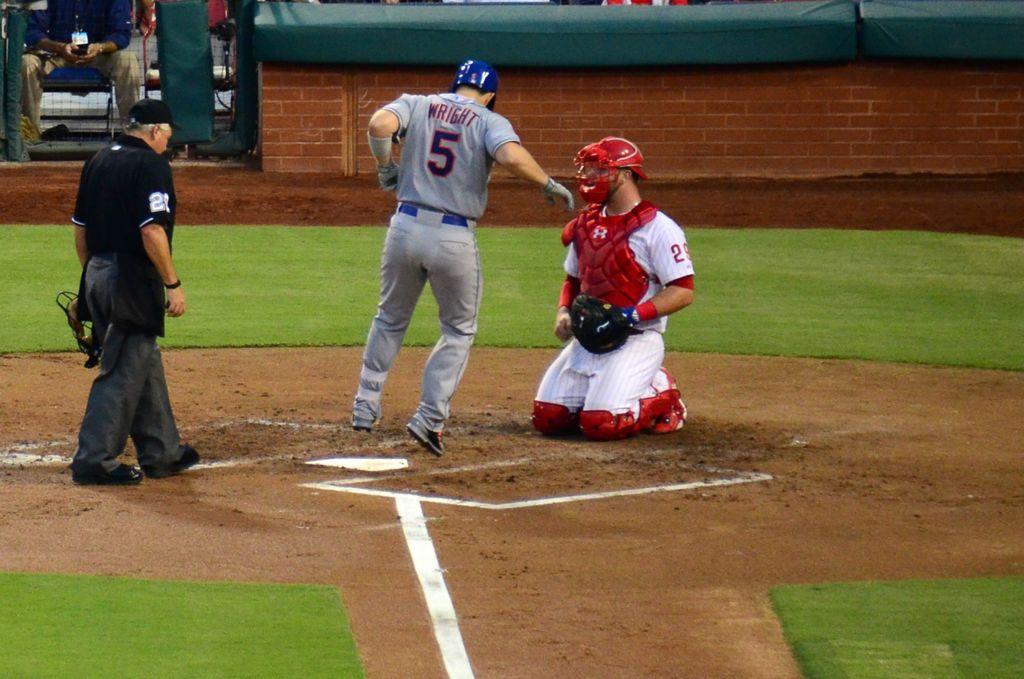What is this player's jersey number?
Your answer should be very brief. 5. Is wright on the field?
Your answer should be compact. Yes. 